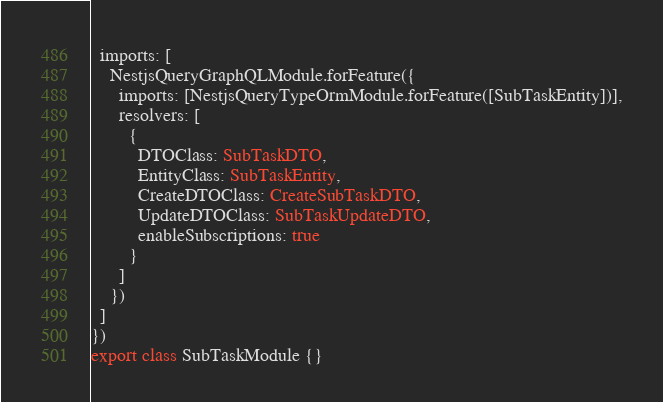<code> <loc_0><loc_0><loc_500><loc_500><_TypeScript_>  imports: [
    NestjsQueryGraphQLModule.forFeature({
      imports: [NestjsQueryTypeOrmModule.forFeature([SubTaskEntity])],
      resolvers: [
        {
          DTOClass: SubTaskDTO,
          EntityClass: SubTaskEntity,
          CreateDTOClass: CreateSubTaskDTO,
          UpdateDTOClass: SubTaskUpdateDTO,
          enableSubscriptions: true
        }
      ]
    })
  ]
})
export class SubTaskModule {}
</code> 